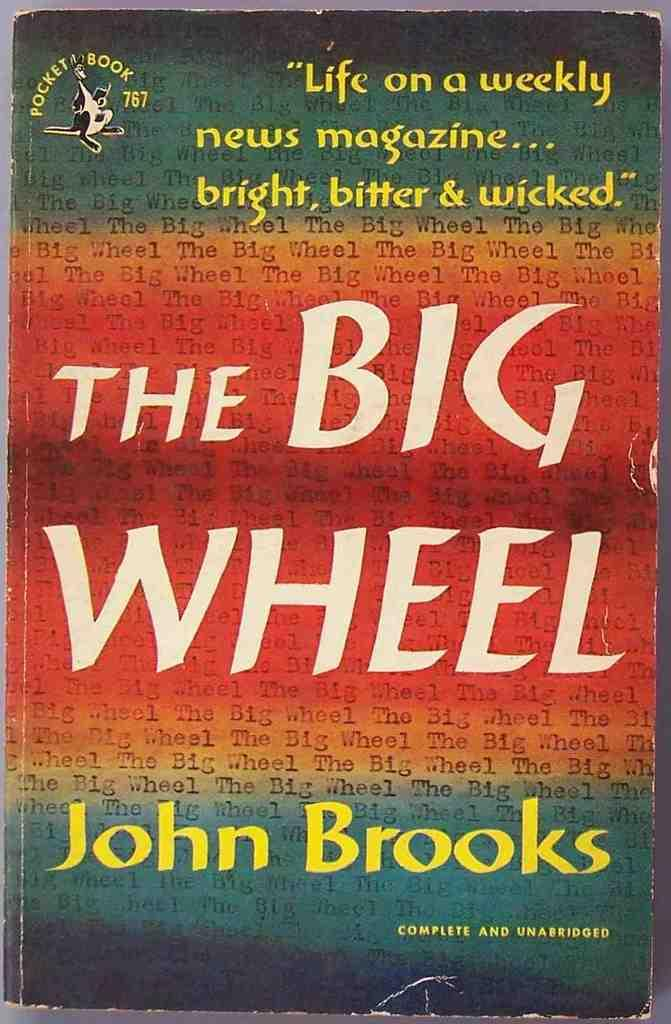<image>
Offer a succinct explanation of the picture presented. A colorful book called The Big Wheel by John Brooks. 